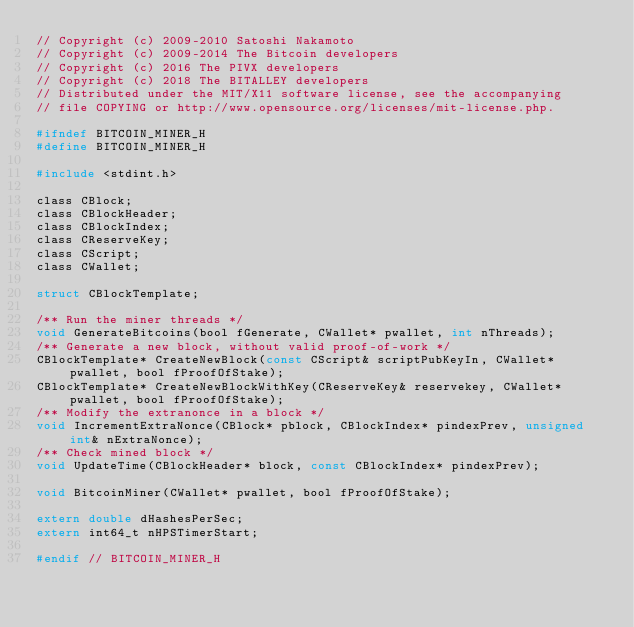<code> <loc_0><loc_0><loc_500><loc_500><_C_>// Copyright (c) 2009-2010 Satoshi Nakamoto
// Copyright (c) 2009-2014 The Bitcoin developers
// Copyright (c) 2016 The PIVX developers
// Copyright (c) 2018 The BITALLEY developers
// Distributed under the MIT/X11 software license, see the accompanying
// file COPYING or http://www.opensource.org/licenses/mit-license.php.

#ifndef BITCOIN_MINER_H
#define BITCOIN_MINER_H

#include <stdint.h>

class CBlock;
class CBlockHeader;
class CBlockIndex;
class CReserveKey;
class CScript;
class CWallet;

struct CBlockTemplate;

/** Run the miner threads */
void GenerateBitcoins(bool fGenerate, CWallet* pwallet, int nThreads);
/** Generate a new block, without valid proof-of-work */
CBlockTemplate* CreateNewBlock(const CScript& scriptPubKeyIn, CWallet* pwallet, bool fProofOfStake);
CBlockTemplate* CreateNewBlockWithKey(CReserveKey& reservekey, CWallet* pwallet, bool fProofOfStake);
/** Modify the extranonce in a block */
void IncrementExtraNonce(CBlock* pblock, CBlockIndex* pindexPrev, unsigned int& nExtraNonce);
/** Check mined block */
void UpdateTime(CBlockHeader* block, const CBlockIndex* pindexPrev);

void BitcoinMiner(CWallet* pwallet, bool fProofOfStake);

extern double dHashesPerSec;
extern int64_t nHPSTimerStart;

#endif // BITCOIN_MINER_H
</code> 